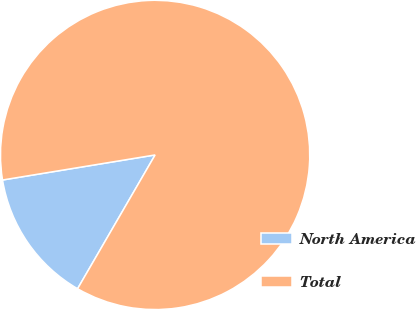<chart> <loc_0><loc_0><loc_500><loc_500><pie_chart><fcel>North America<fcel>Total<nl><fcel>14.05%<fcel>85.95%<nl></chart> 